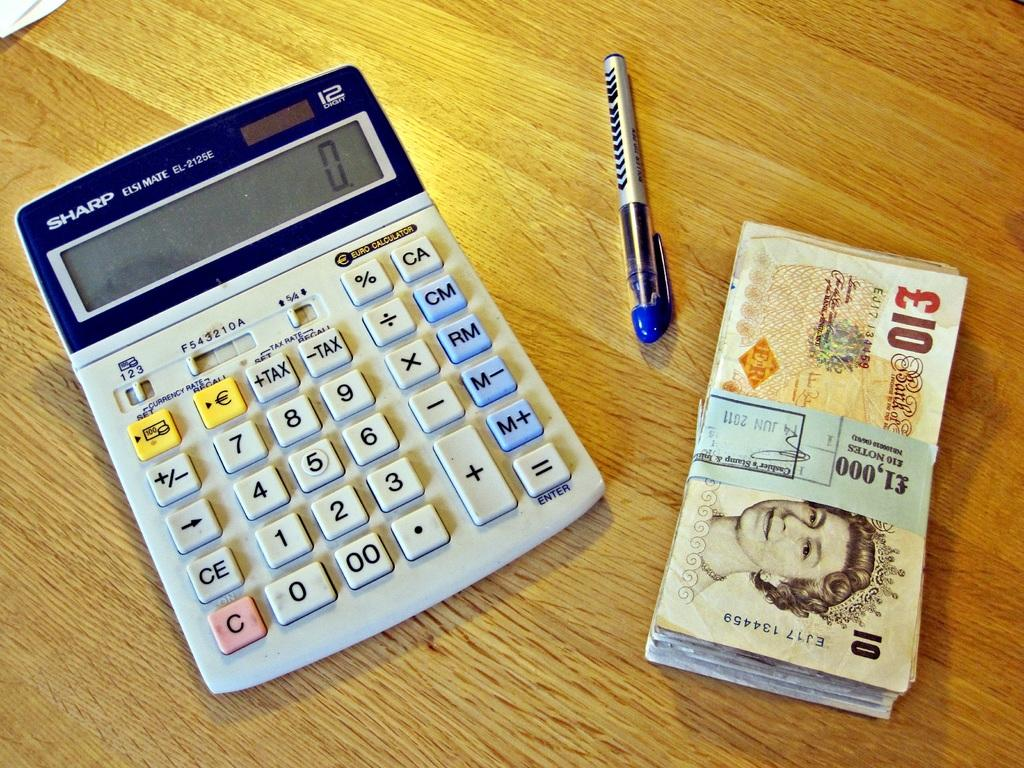Provide a one-sentence caption for the provided image. A Sharp calculator sits on a table next to a stack of 100 10 pound notes. 